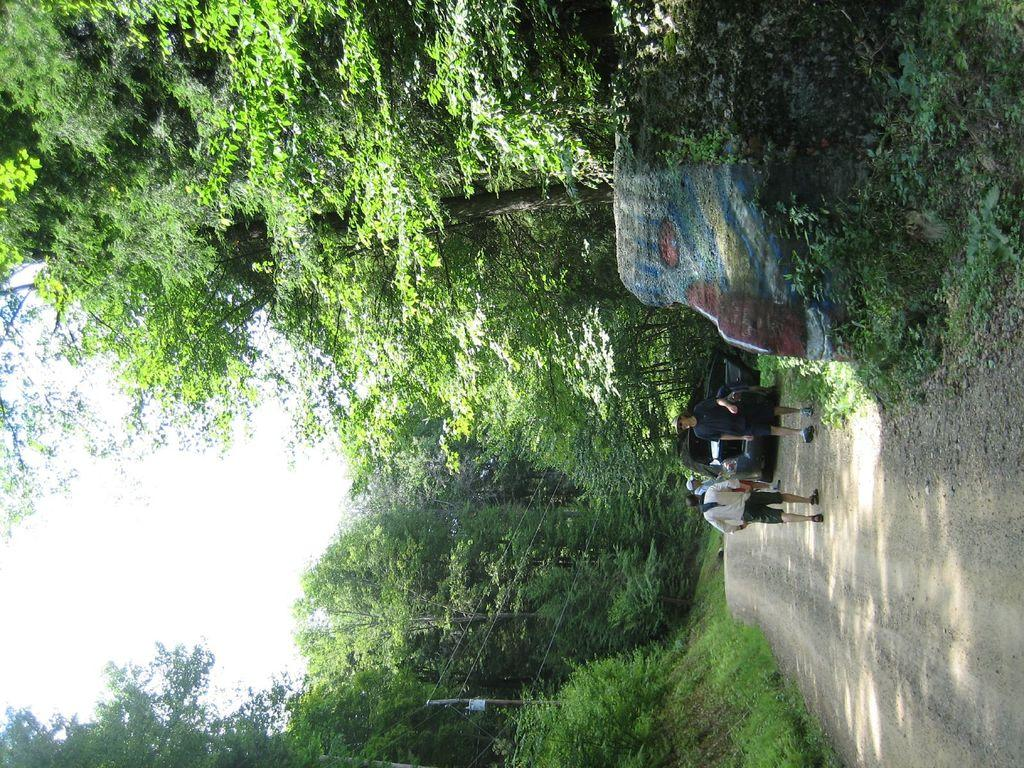What is the main subject in the image? There is a vehicle in the image. Can you describe the people in the image? There are three people on the road in the image. What type of natural elements can be seen in the image? There are rocks, plants, and trees in the image. What man-made structures are present in the image? There is a pole in the image, and there are wires visible as well. What can be seen in the background of the image? The sky is visible in the background of the image. How many cats are sitting on the vehicle in the image? There are no cats present in the image. What type of bubble is floating near the trees in the image? There is no bubble present in the image. 